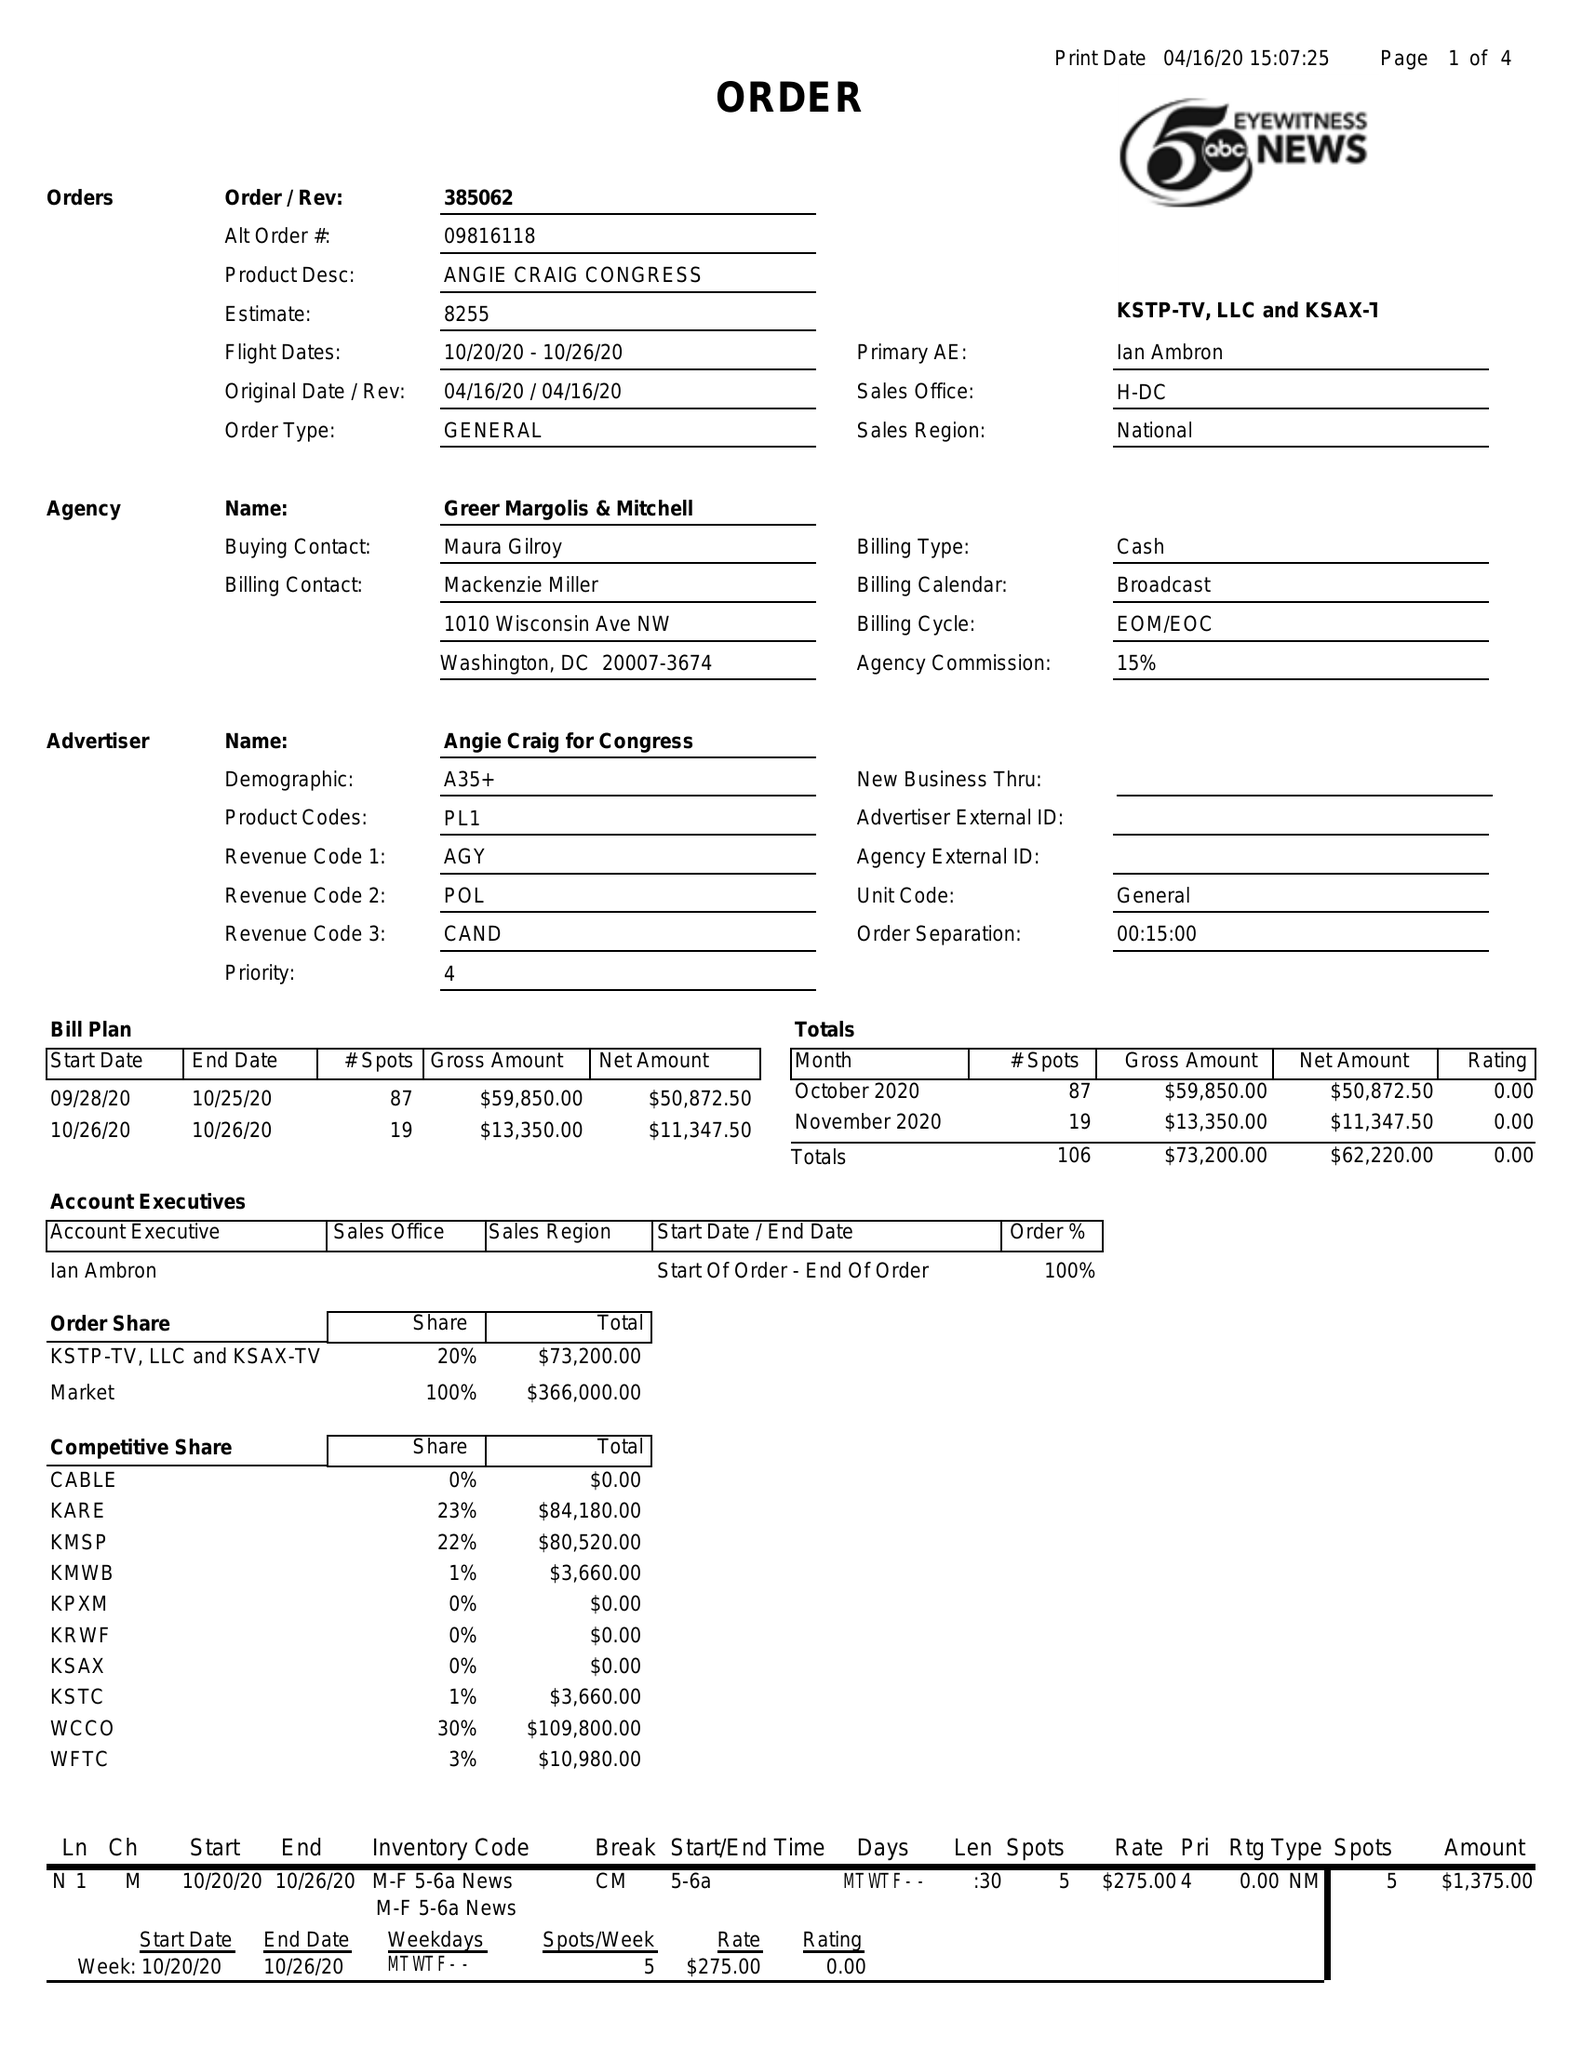What is the value for the flight_from?
Answer the question using a single word or phrase. 10/20/20 